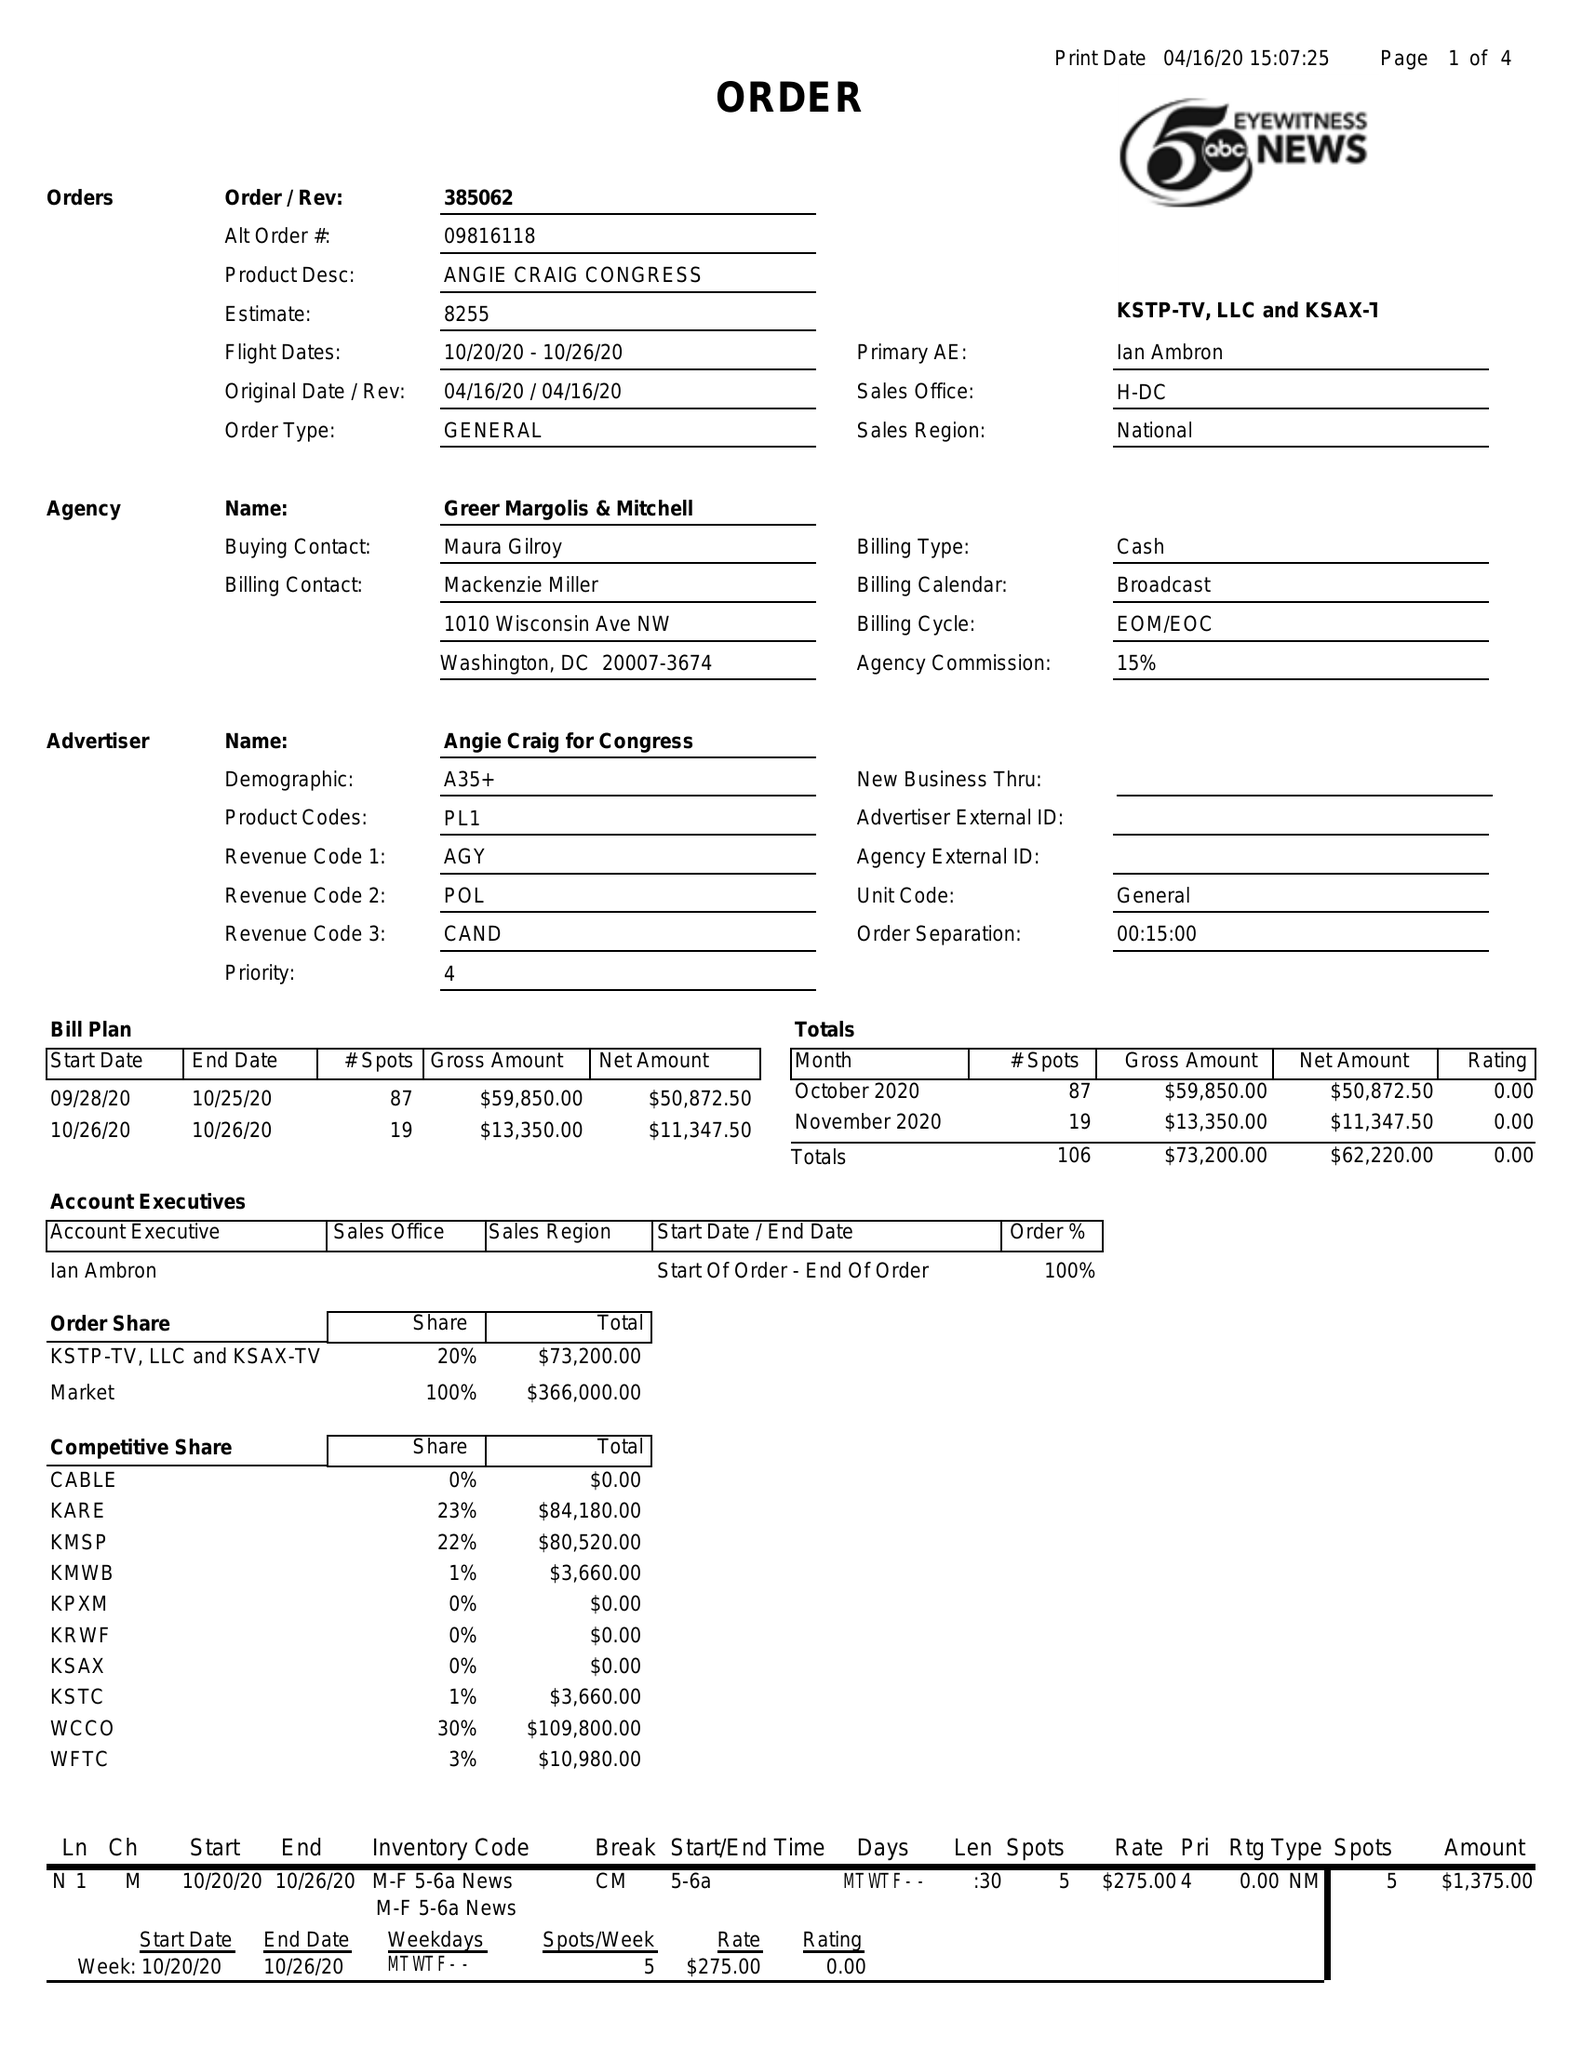What is the value for the flight_from?
Answer the question using a single word or phrase. 10/20/20 